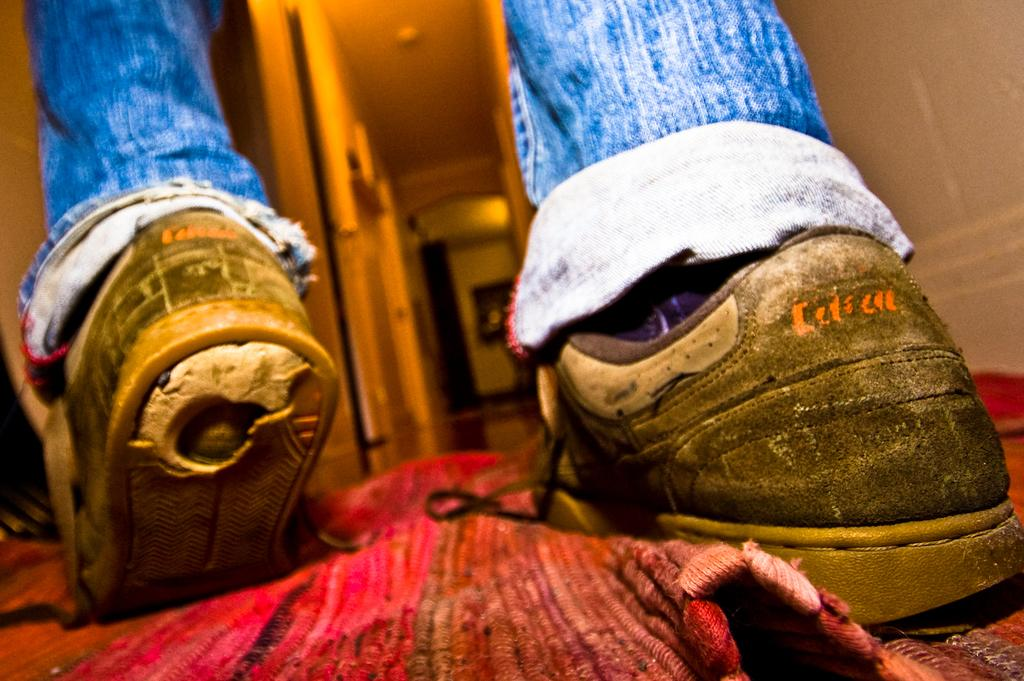What part of a person can be seen in the image? There are legs of a person visible in the image. What type of footwear is the person wearing? The person is wearing shoes. What is on the floor in the image? There is a carpet on the floor in the image. What type of spade is the person holding in the image? There is no spade present in the image; only the person's legs and shoes are visible. 